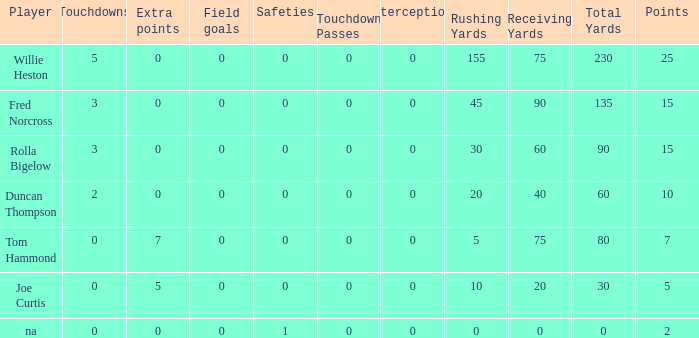Which Points is the lowest one that has Touchdowns smaller than 2, and an Extra points of 7, and a Field goals smaller than 0? None. 